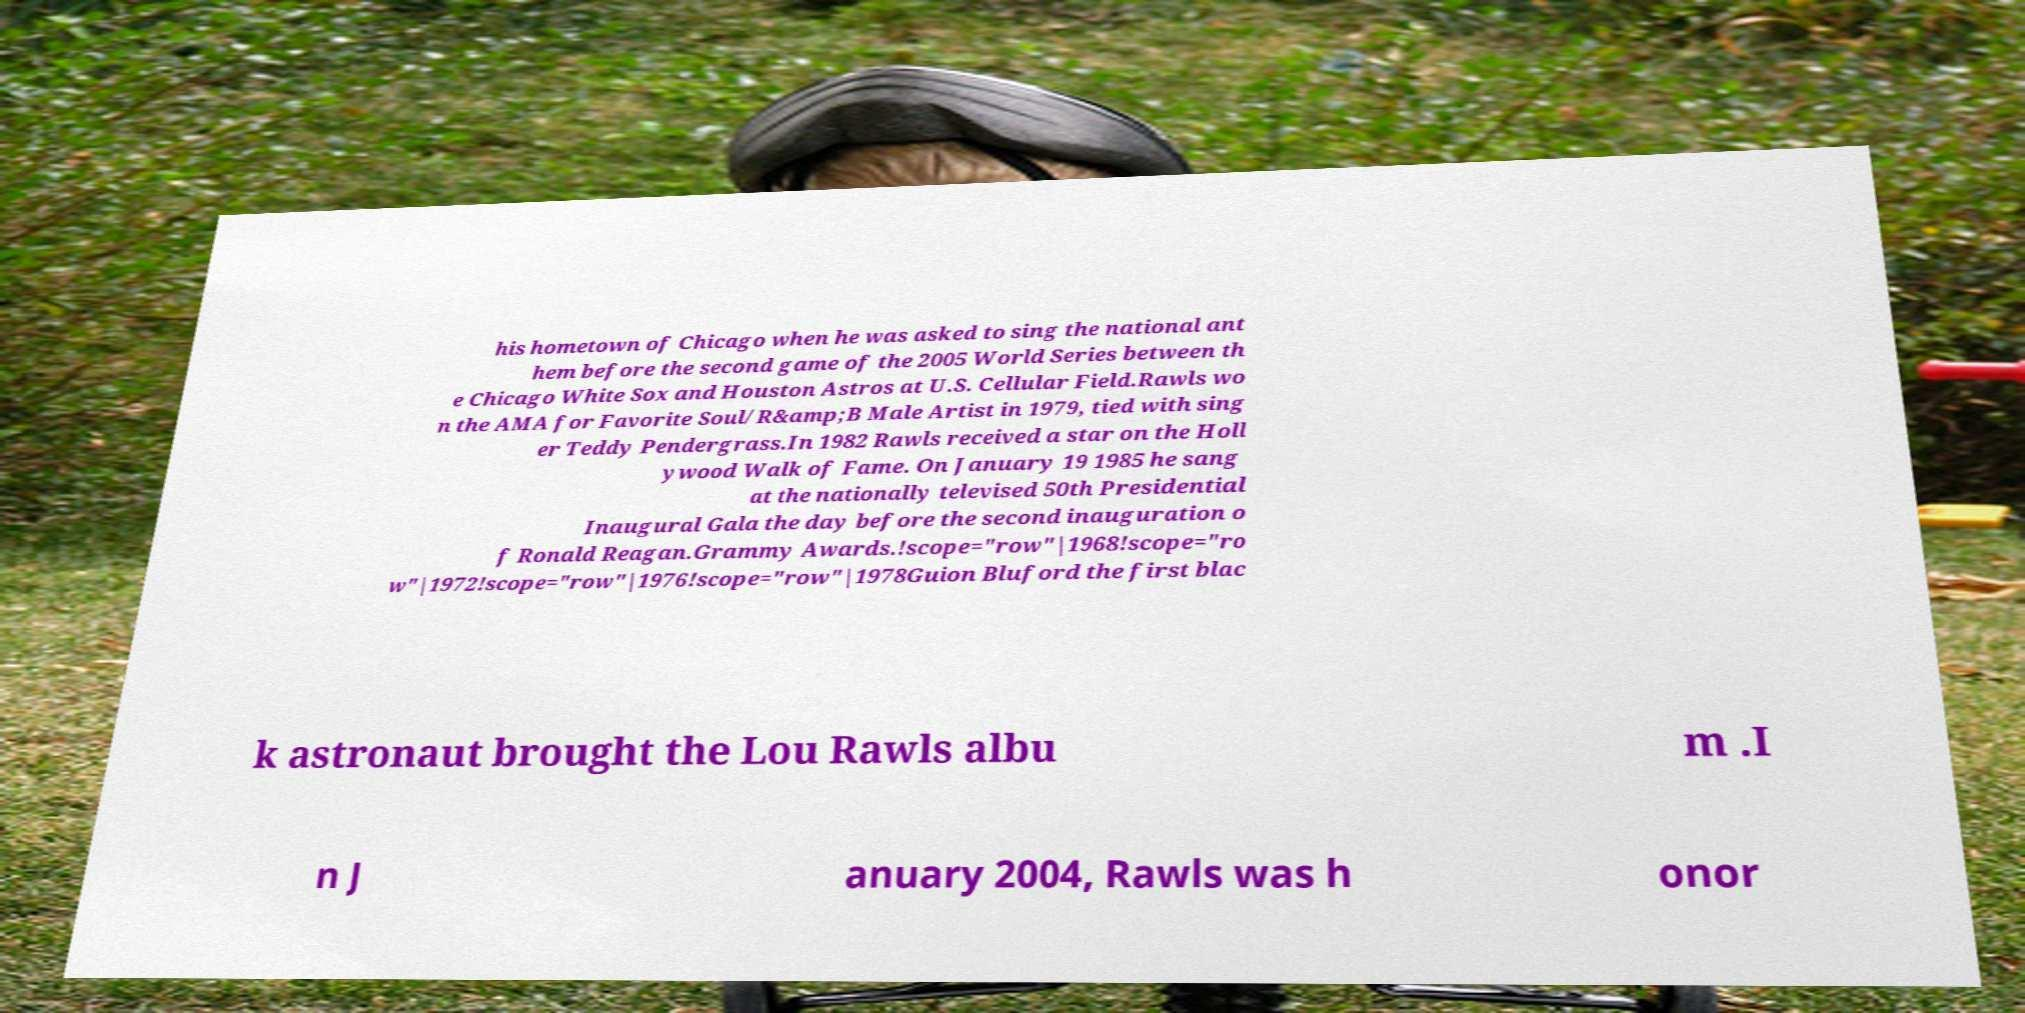Can you accurately transcribe the text from the provided image for me? his hometown of Chicago when he was asked to sing the national ant hem before the second game of the 2005 World Series between th e Chicago White Sox and Houston Astros at U.S. Cellular Field.Rawls wo n the AMA for Favorite Soul/R&amp;B Male Artist in 1979, tied with sing er Teddy Pendergrass.In 1982 Rawls received a star on the Holl ywood Walk of Fame. On January 19 1985 he sang at the nationally televised 50th Presidential Inaugural Gala the day before the second inauguration o f Ronald Reagan.Grammy Awards.!scope="row"|1968!scope="ro w"|1972!scope="row"|1976!scope="row"|1978Guion Bluford the first blac k astronaut brought the Lou Rawls albu m .I n J anuary 2004, Rawls was h onor 